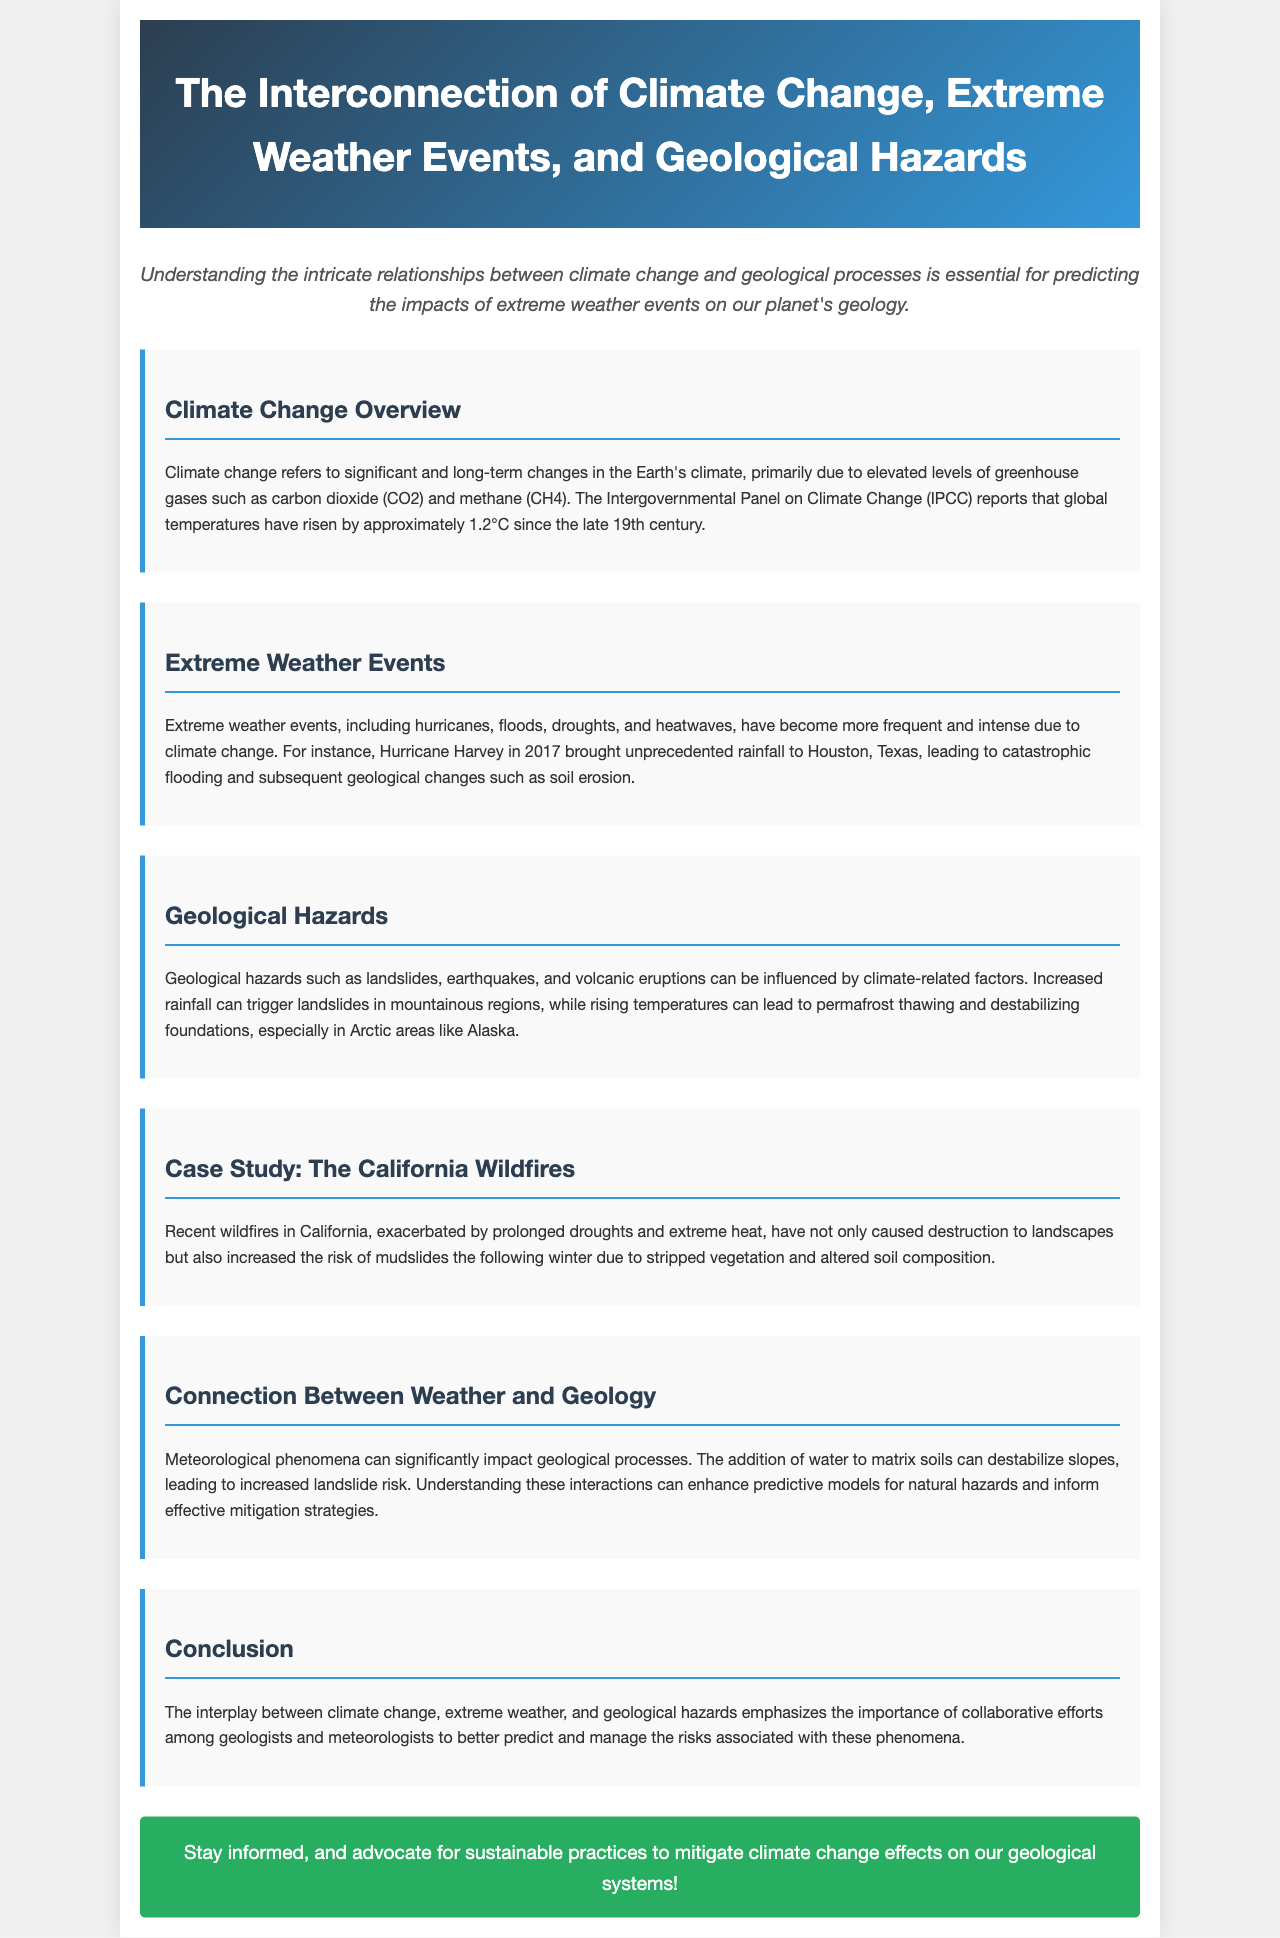What has been the temperature rise since the late 19th century? The document mentions that global temperatures have risen by approximately 1.2°C since the late 19th century.
Answer: 1.2°C What are examples of extreme weather events mentioned? The document lists hurricanes, floods, droughts, and heatwaves as examples of extreme weather events.
Answer: Hurricanes, floods, droughts, heatwaves What geological hazard can be triggered by increased rainfall? The document states increased rainfall can trigger landslides in mountainous regions.
Answer: Landslides What case study is highlighted in the document? The document specifically mentions California wildfires as a case study related to extreme weather and geological hazards.
Answer: California Wildfires What effect does the addition of water to matrix soils have? The document explains that the addition of water to matrix soils can destabilize slopes, leading to increased landslide risk.
Answer: Destabilize slopes What is emphasized in the conclusion regarding the collaboration of scientists? The conclusion emphasizes the importance of collaborative efforts among geologists and meteorologists to manage risks.
Answer: Collaborative efforts How do wildfires in California relate to geological hazards? The document states that wildfires increase the risk of mudslides the following winter due to stripped vegetation and altered soil composition.
Answer: Increased risk of mudslides 